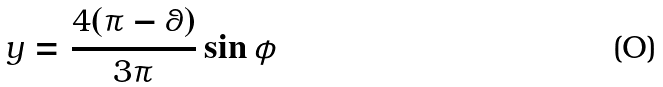<formula> <loc_0><loc_0><loc_500><loc_500>y = \frac { 4 ( \pi - \theta ) } { 3 \pi } \sin \phi</formula> 